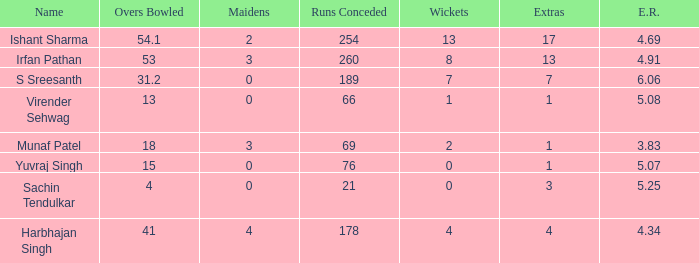Name the name for when overs bowled is 31.2 S Sreesanth. 